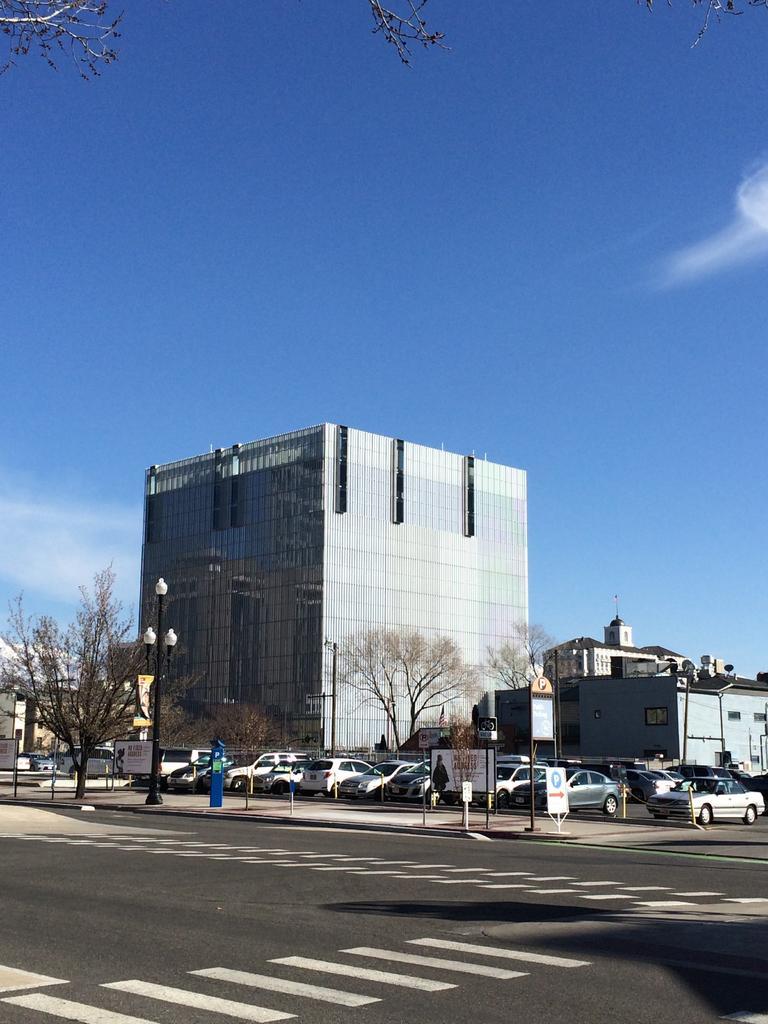Please provide a concise description of this image. In this image we can see road, cars, trees, poles and buildings. Behind the building, the sky is there. At the top left of the image tree branch is present. 